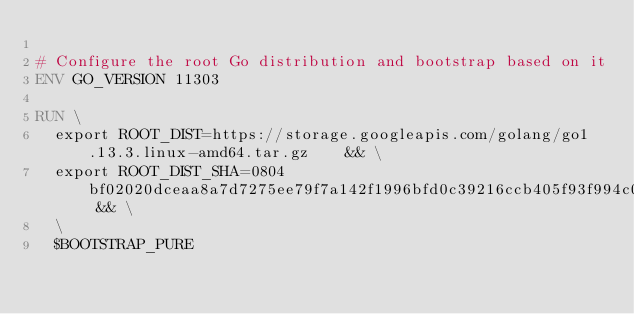<code> <loc_0><loc_0><loc_500><loc_500><_Dockerfile_>
# Configure the root Go distribution and bootstrap based on it
ENV GO_VERSION 11303

RUN \
  export ROOT_DIST=https://storage.googleapis.com/golang/go1.13.3.linux-amd64.tar.gz    && \
  export ROOT_DIST_SHA=0804bf02020dceaa8a7d7275ee79f7a142f1996bfd0c39216ccb405f93f994c0 && \
  \
  $BOOTSTRAP_PURE
</code> 